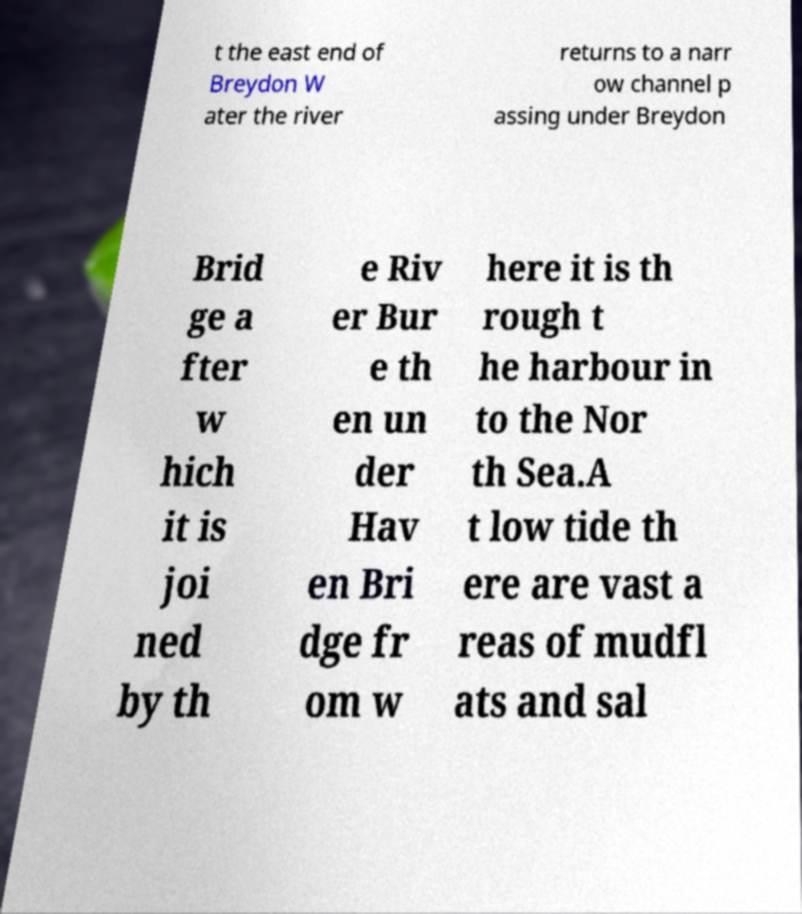Could you extract and type out the text from this image? t the east end of Breydon W ater the river returns to a narr ow channel p assing under Breydon Brid ge a fter w hich it is joi ned by th e Riv er Bur e th en un der Hav en Bri dge fr om w here it is th rough t he harbour in to the Nor th Sea.A t low tide th ere are vast a reas of mudfl ats and sal 